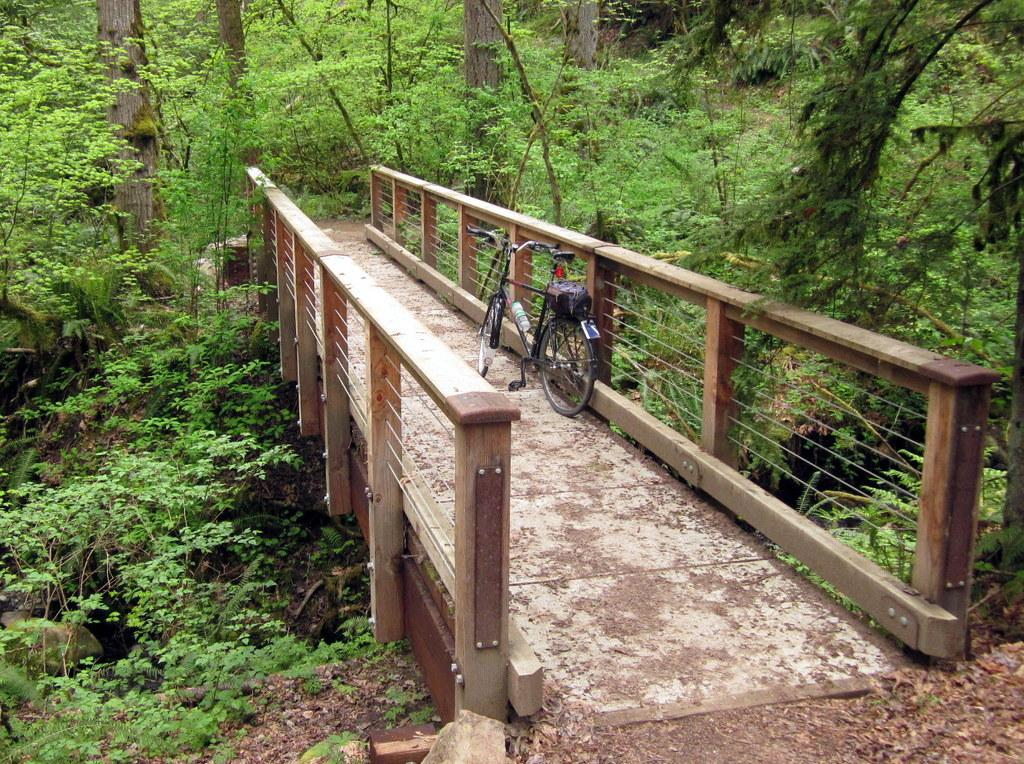What is the main object in the image? There is a bicycle in the image. Where is the bicycle located? The bicycle is parked on a bridge. What type of natural elements can be seen in the image? There are trees and plants in the image. What is present on the surface in the image? Dry leaves are present on the surface in the image. What type of marble can be seen on the bridge in the image? There is no marble present on the bridge in the image. How many flowers are visible on the trees in the image? There are no flowers visible on the trees in the image; only trees and plants are present. 